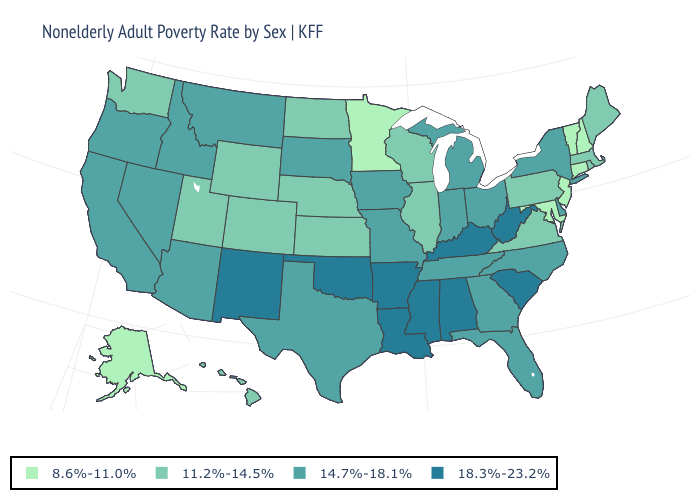How many symbols are there in the legend?
Keep it brief. 4. Which states hav the highest value in the MidWest?
Quick response, please. Indiana, Iowa, Michigan, Missouri, Ohio, South Dakota. Among the states that border Minnesota , does North Dakota have the highest value?
Keep it brief. No. What is the value of Kansas?
Concise answer only. 11.2%-14.5%. Name the states that have a value in the range 14.7%-18.1%?
Quick response, please. Arizona, California, Delaware, Florida, Georgia, Idaho, Indiana, Iowa, Michigan, Missouri, Montana, Nevada, New York, North Carolina, Ohio, Oregon, South Dakota, Tennessee, Texas. What is the highest value in the USA?
Concise answer only. 18.3%-23.2%. What is the highest value in states that border Tennessee?
Write a very short answer. 18.3%-23.2%. Which states have the lowest value in the South?
Short answer required. Maryland. Which states have the lowest value in the USA?
Write a very short answer. Alaska, Connecticut, Maryland, Minnesota, New Hampshire, New Jersey, Vermont. Is the legend a continuous bar?
Write a very short answer. No. What is the lowest value in the Northeast?
Keep it brief. 8.6%-11.0%. Name the states that have a value in the range 8.6%-11.0%?
Give a very brief answer. Alaska, Connecticut, Maryland, Minnesota, New Hampshire, New Jersey, Vermont. Name the states that have a value in the range 18.3%-23.2%?
Short answer required. Alabama, Arkansas, Kentucky, Louisiana, Mississippi, New Mexico, Oklahoma, South Carolina, West Virginia. What is the value of Indiana?
Quick response, please. 14.7%-18.1%. 